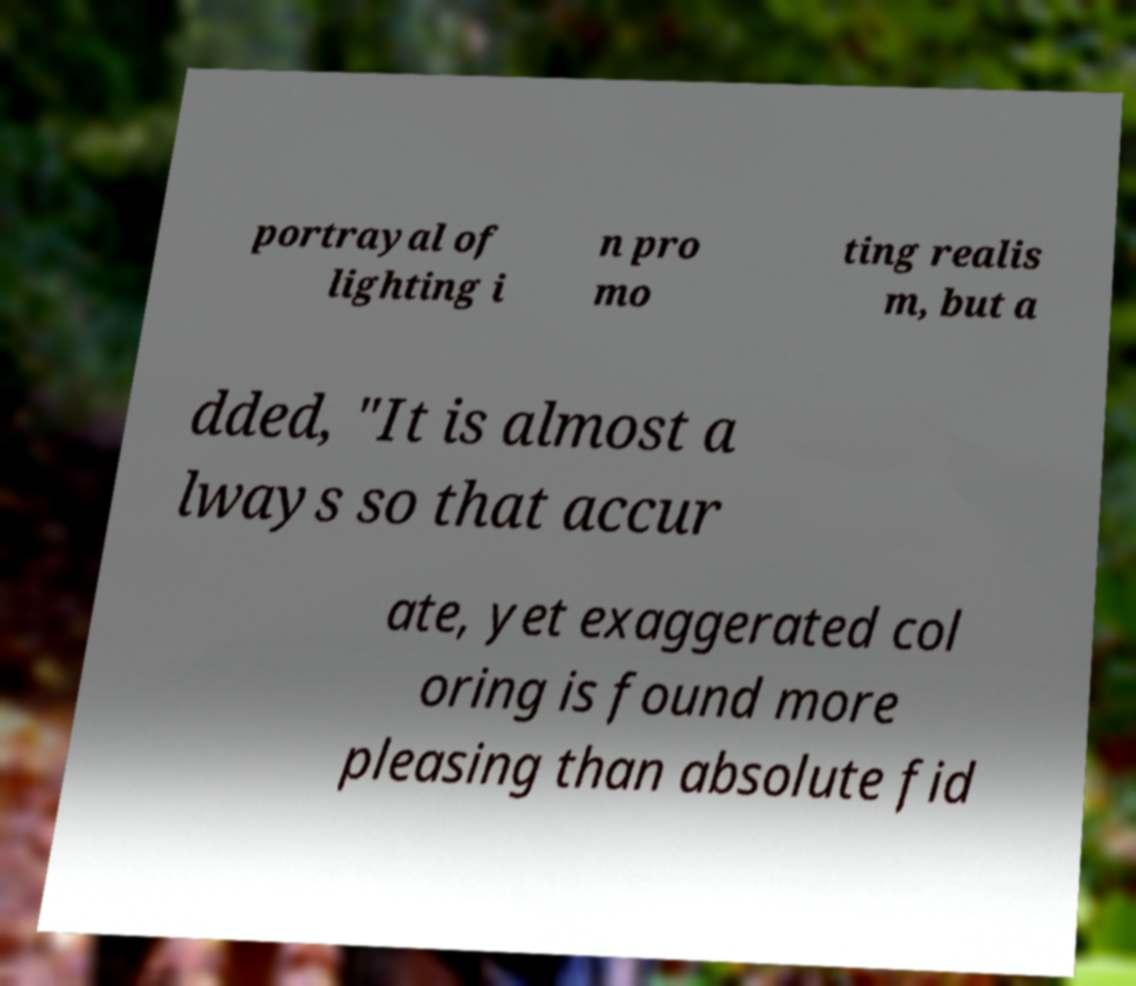Please read and relay the text visible in this image. What does it say? portrayal of lighting i n pro mo ting realis m, but a dded, "It is almost a lways so that accur ate, yet exaggerated col oring is found more pleasing than absolute fid 